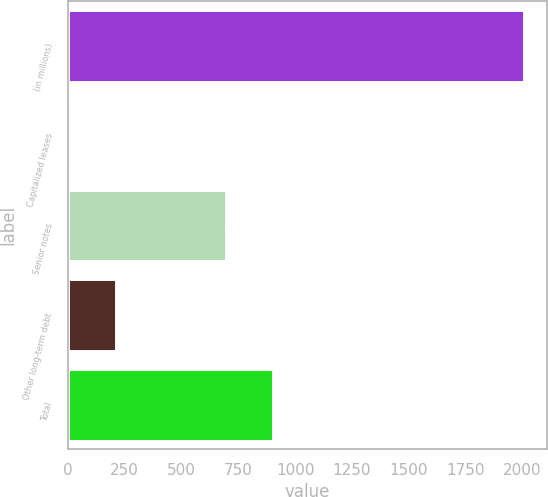<chart> <loc_0><loc_0><loc_500><loc_500><bar_chart><fcel>(in millions)<fcel>Capitalized leases<fcel>Senior notes<fcel>Other long-term debt<fcel>Total<nl><fcel>2005<fcel>13<fcel>697<fcel>212.2<fcel>901<nl></chart> 